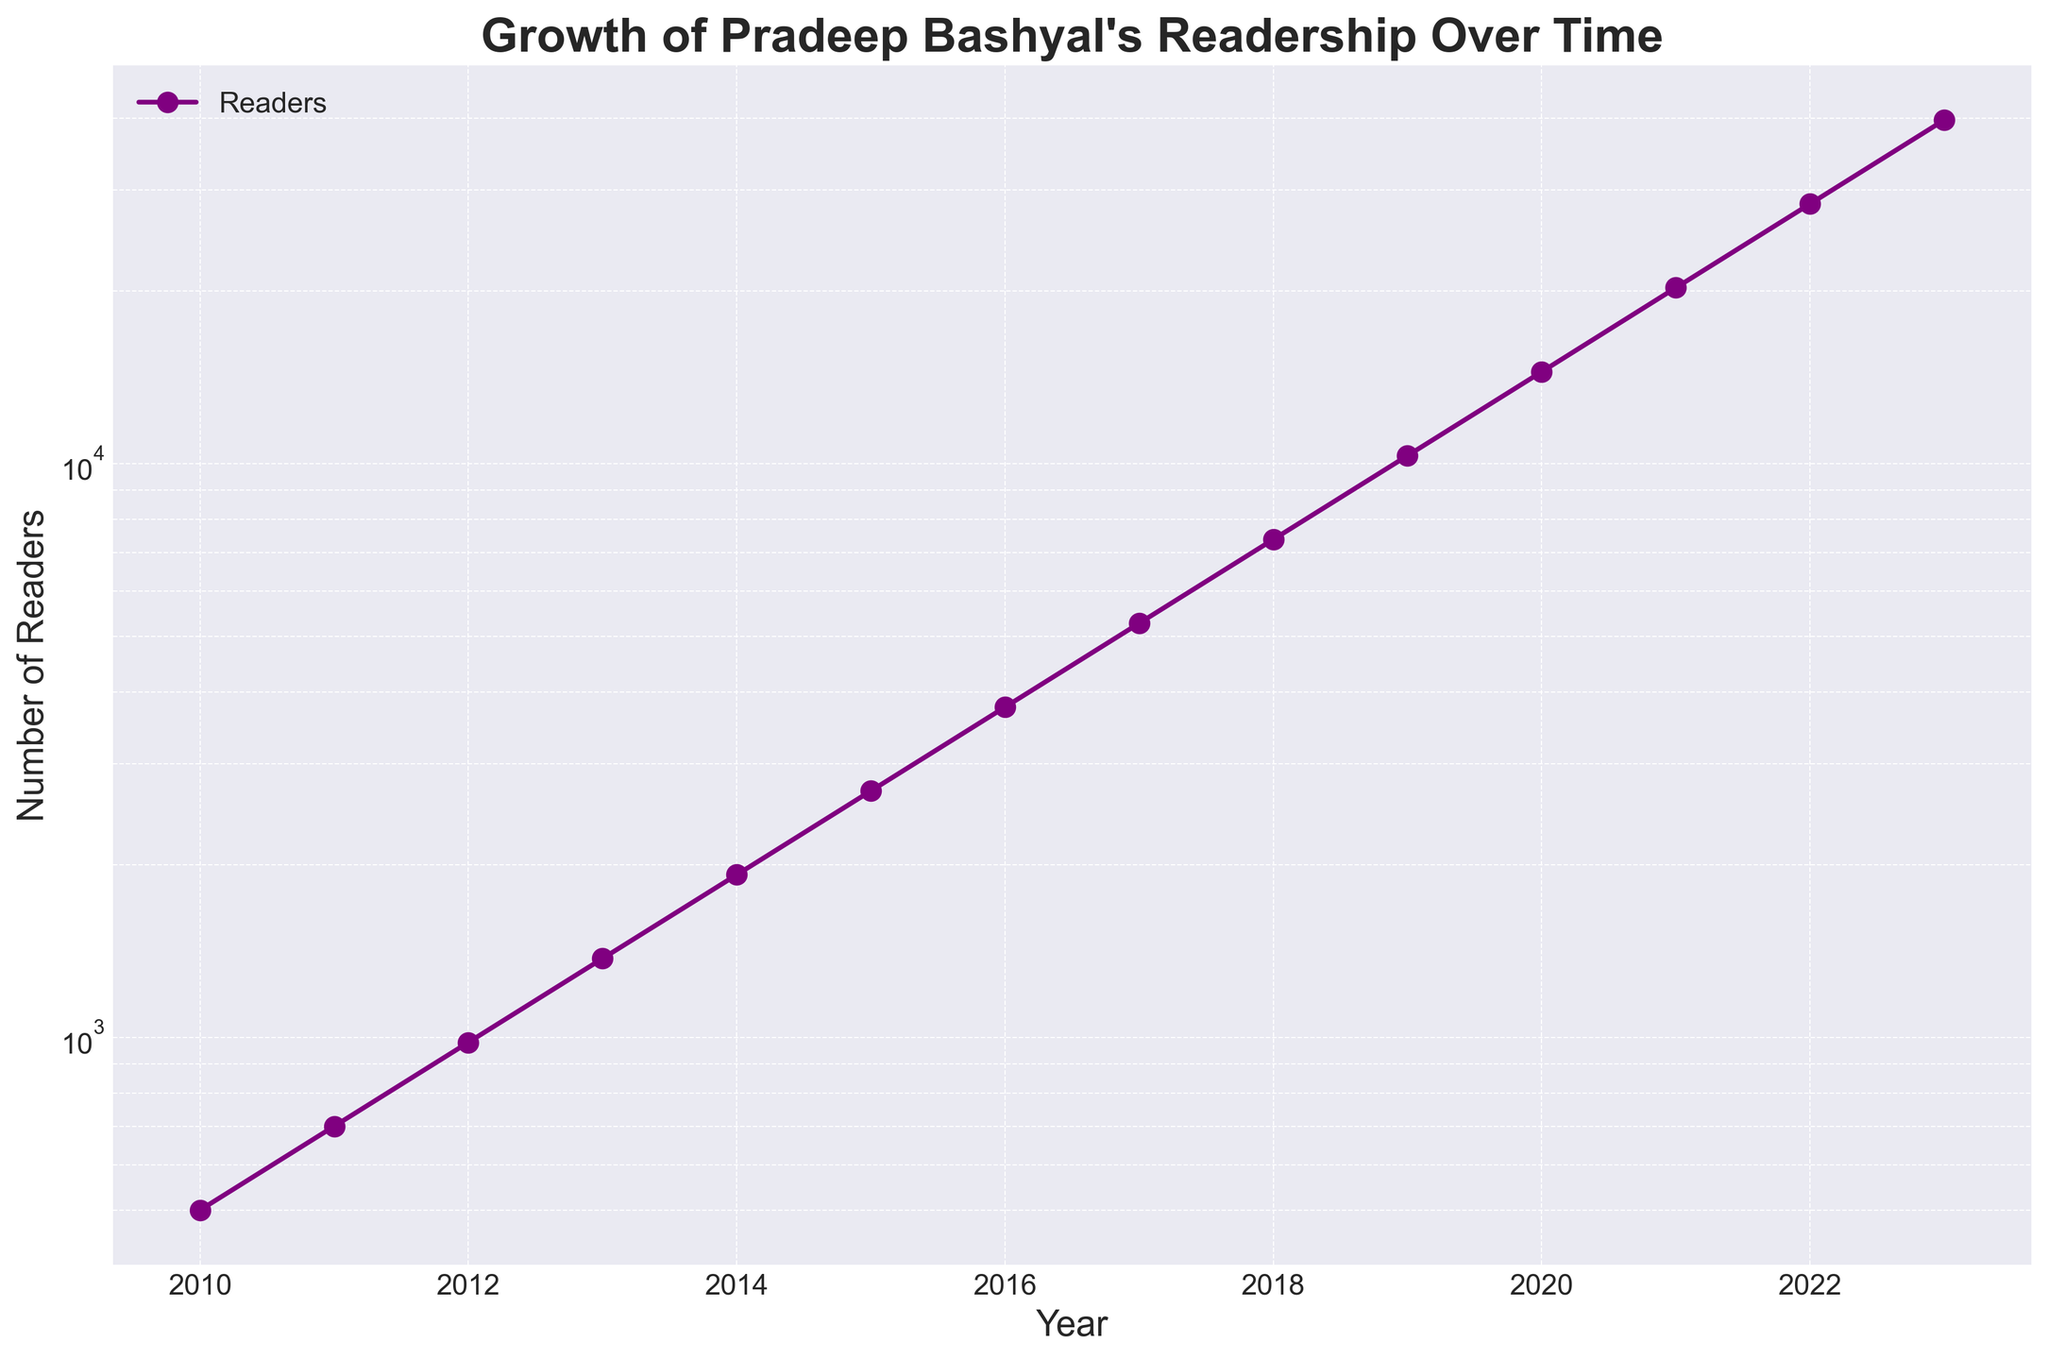What kind of trend is depicted in the figure? The plot shows the number of readers for Pradeep Bashyal's works over time, which increases exponentially, as indicated by the upward curve shown on a logarithmic scale. The consistent rise each year signifies exponential growth.
Answer: Exponential growth By how much did the number of readers increase from 2015 to 2020? In 2015, there were 2688 readers, and in 2020, there were 14450. The difference is 14450 - 2688 = 11762.
Answer: 11762 In which year did the number of readers first exceed 10,000? By examining the data points on the curve, the figure shows that in 2019, the number of readers was 10321, which is the first instance when it exceeded 10,000 readers.
Answer: 2019 How can one describe the pace of readership growth from 2010 to 2023? The plot shows a slow initial increase followed by a much steeper rise in the later years, typical of exponential growth. The curve's slope significantly increases as years progress, showing rapid reader growth.
Answer: Rapid, exponential growth What was the approximate number of readers in 2012, and how did it change by 2016? In 2012, the number of readers was approximately 980 and by 2016, it had increased to around 3763. The difference in readers is 3763 - 980 = 2783.
Answer: 2783 Compare the growth rate between the decade from 2010 to 2020 and the subsequent three years. From 2010 (500 readers) to 2020 (14450 readers), the number of readers grew by 14450 - 500 = 13950. From 2020 to 2023, the readers increased from 14450 to 39682, growing by 39682 - 14450 = 25232. Clearly, the growth rate was much higher in the subsequent three years compared to the first decade.
Answer: Higher in subsequent three years What is the significance of using a logarithmic scale on the y-axis for this plot? The logarithmic scale helps to visualize the exponential growth more clearly because it scales the data logarithmically, making it easier to observe trends over time and understand the rapid increase in readership.
Answer: Visualizing exponential growth Can you identify a year where the readership roughly doubled from the previous year? From the plot, examining each point reveals that the readership nearly doubled from 2019 (10321 readers) to 2020 (14450 readers).
Answer: 2020 What visual feature of the plot indicates the exponential nature of the reader growth? The steepness and curvature of the line on a logarithmic scale indicate exponential growth. The line starting to curve upwards significantly represents the rapid increase in readers over time.
Answer: Steep, upward curve 